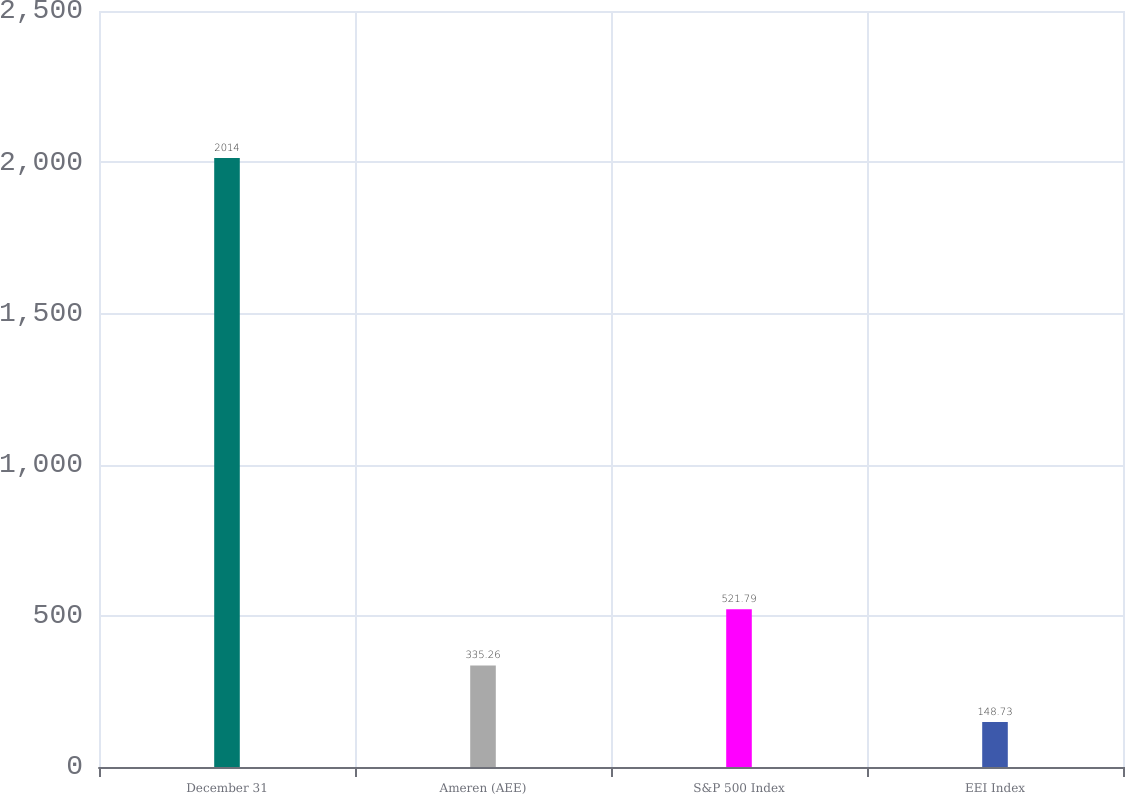<chart> <loc_0><loc_0><loc_500><loc_500><bar_chart><fcel>December 31<fcel>Ameren (AEE)<fcel>S&P 500 Index<fcel>EEI Index<nl><fcel>2014<fcel>335.26<fcel>521.79<fcel>148.73<nl></chart> 